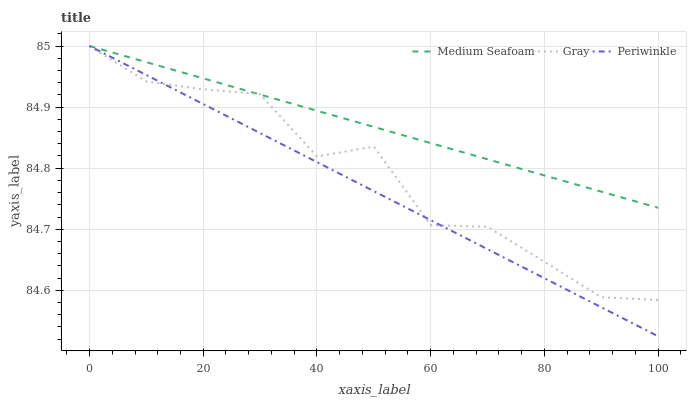Does Periwinkle have the minimum area under the curve?
Answer yes or no. Yes. Does Medium Seafoam have the maximum area under the curve?
Answer yes or no. Yes. Does Medium Seafoam have the minimum area under the curve?
Answer yes or no. No. Does Periwinkle have the maximum area under the curve?
Answer yes or no. No. Is Medium Seafoam the smoothest?
Answer yes or no. Yes. Is Gray the roughest?
Answer yes or no. Yes. Is Periwinkle the smoothest?
Answer yes or no. No. Is Periwinkle the roughest?
Answer yes or no. No. Does Medium Seafoam have the lowest value?
Answer yes or no. No. Does Medium Seafoam have the highest value?
Answer yes or no. Yes. Does Medium Seafoam intersect Periwinkle?
Answer yes or no. Yes. Is Medium Seafoam less than Periwinkle?
Answer yes or no. No. Is Medium Seafoam greater than Periwinkle?
Answer yes or no. No. 